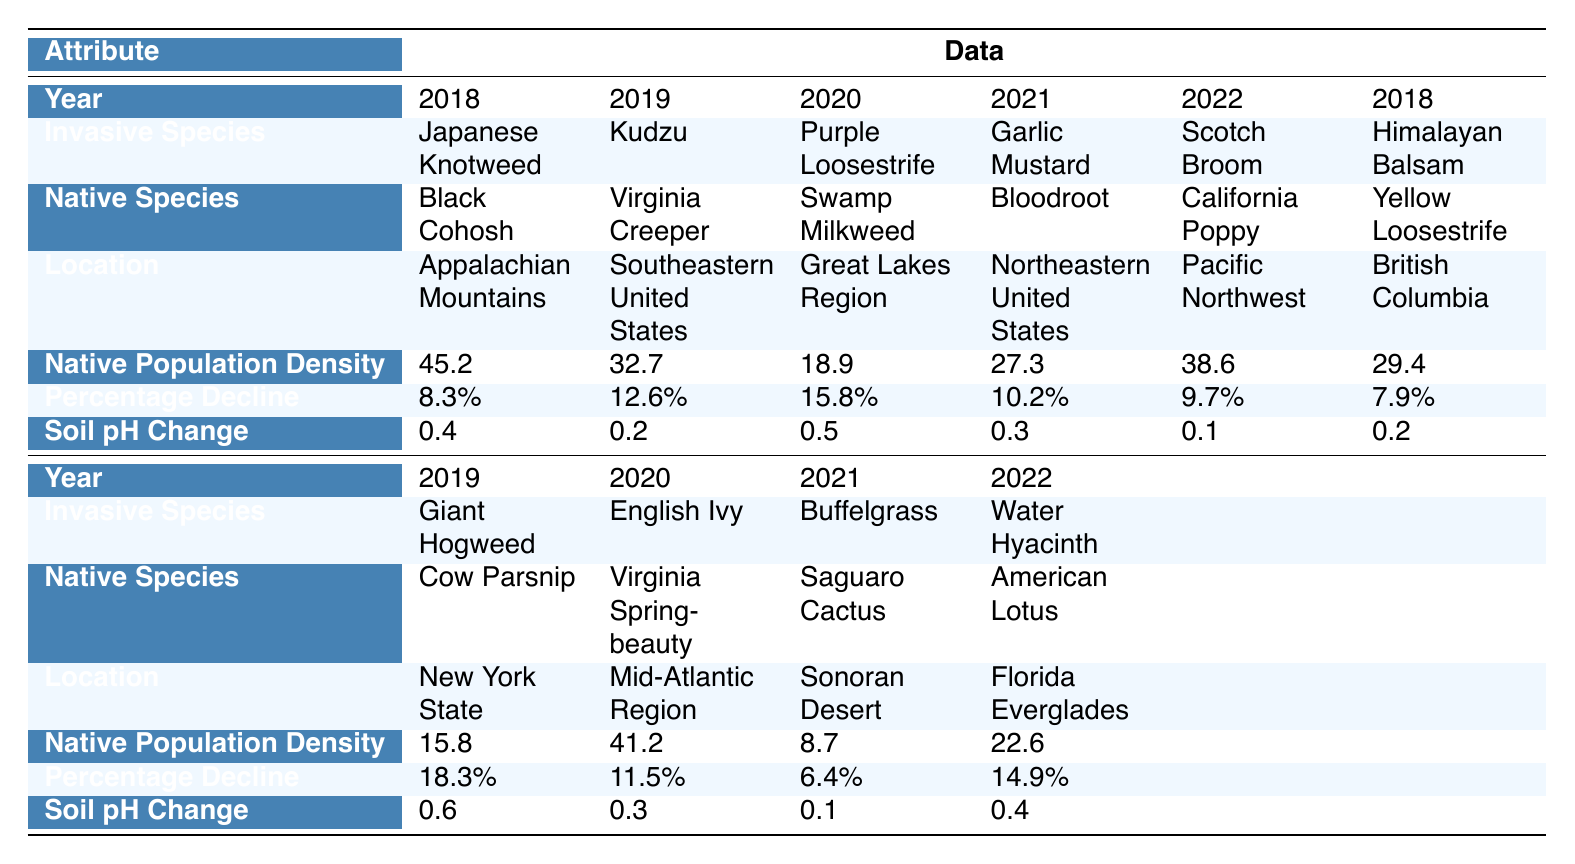What invasive species caused the greatest percentage decline in native flora in 2020? In 2020, the invasive species that caused the greatest percentage decline is Purple Loosestrife, with a decline of 15.8%.
Answer: Purple Loosestrife What was the native population density of Bloodroot in 2021? In 2021, the native population density of Bloodroot was 27.3 individuals per unit area.
Answer: 27.3 Was there any increase in soil pH due to invasive species over the 5-year period? A soil pH change is recorded for each year, and all the values are non-negative, indicating no decreases; therefore, the average does not indicate any increase overall.
Answer: No Which invasive species was observed in the Appalachian Mountains? The invasive species observed in the Appalachian Mountains is Japanese Knotweed.
Answer: Japanese Knotweed What is the average percentage decline of native species in 2019? In 2019, there are two cases: Kudzu's decline is 12.6% and Giant Hogweed's is 18.3%. The average is (12.6 + 18.3) / 2 = 15.45%.
Answer: 15.45% In which location did Scotch Broom impact native flora? Scotch Broom impacted native flora in the Pacific Northwest.
Answer: Pacific Northwest What is the change in soil pH for Virginia Creeper due to invasive Kudzu in 2019? The soil pH change for Virginia Creeper caused by Kudzu is 0.2.
Answer: 0.2 What is the difference between the native population density of California Poppy and Yellow Loosestrife in 2022? In 2022, California Poppy's density is 38.6 and Yellow Loosestrife's density is 29.4. The difference is 38.6 - 29.4 = 9.2.
Answer: 9.2 Which invasive species had the least impact on the population of its native counterpart? The invasive species with the least impact based on percentage decline is Buffelgrass with a 6.4% decline of Saguaro Cactus.
Answer: Buffelgrass What was the native population density for Swamp Milkweed in 2020, and how does it compare to that of Bloodroot in 2021? Swamp Milkweed had a density of 18.9 in 2020 and Bloodroot had 27.3 in 2021. Comparing the values: 27.3 - 18.9 = 8.4, indicating Bloodroot's density was higher by 8.4.
Answer: Higher by 8.4 